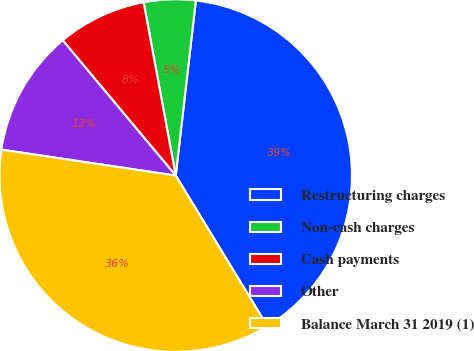Convert chart. <chart><loc_0><loc_0><loc_500><loc_500><pie_chart><fcel>Restructuring charges<fcel>Non-cash charges<fcel>Cash payments<fcel>Other<fcel>Balance March 31 2019 (1)<nl><fcel>39.47%<fcel>4.74%<fcel>8.16%<fcel>11.57%<fcel>36.05%<nl></chart> 